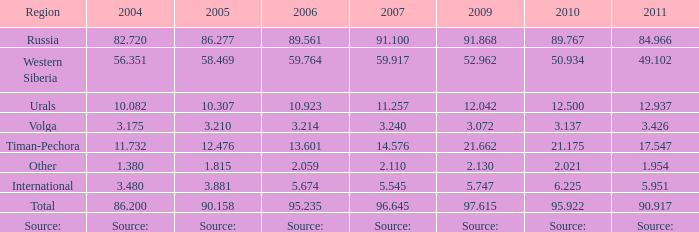Parse the full table. {'header': ['Region', '2004', '2005', '2006', '2007', '2009', '2010', '2011'], 'rows': [['Russia', '82.720', '86.277', '89.561', '91.100', '91.868', '89.767', '84.966'], ['Western Siberia', '56.351', '58.469', '59.764', '59.917', '52.962', '50.934', '49.102'], ['Urals', '10.082', '10.307', '10.923', '11.257', '12.042', '12.500', '12.937'], ['Volga', '3.175', '3.210', '3.214', '3.240', '3.072', '3.137', '3.426'], ['Timan-Pechora', '11.732', '12.476', '13.601', '14.576', '21.662', '21.175', '17.547'], ['Other', '1.380', '1.815', '2.059', '2.110', '2.130', '2.021', '1.954'], ['International', '3.480', '3.881', '5.674', '5.545', '5.747', '6.225', '5.951'], ['Total', '86.200', '90.158', '95.235', '96.645', '97.615', '95.922', '90.917'], ['Source:', 'Source:', 'Source:', 'Source:', 'Source:', 'Source:', 'Source:', 'Source:']]} What is the 2010 lukoil oil production when in 2009 oil extraction was 2 21.175. 